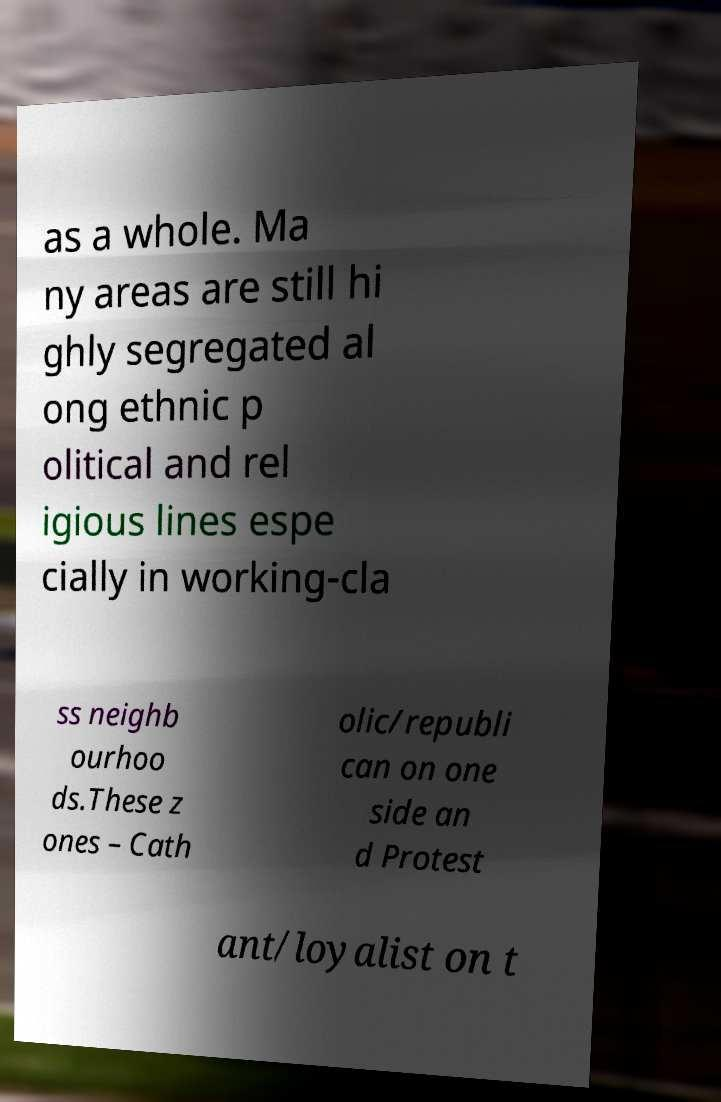Could you assist in decoding the text presented in this image and type it out clearly? as a whole. Ma ny areas are still hi ghly segregated al ong ethnic p olitical and rel igious lines espe cially in working-cla ss neighb ourhoo ds.These z ones – Cath olic/republi can on one side an d Protest ant/loyalist on t 